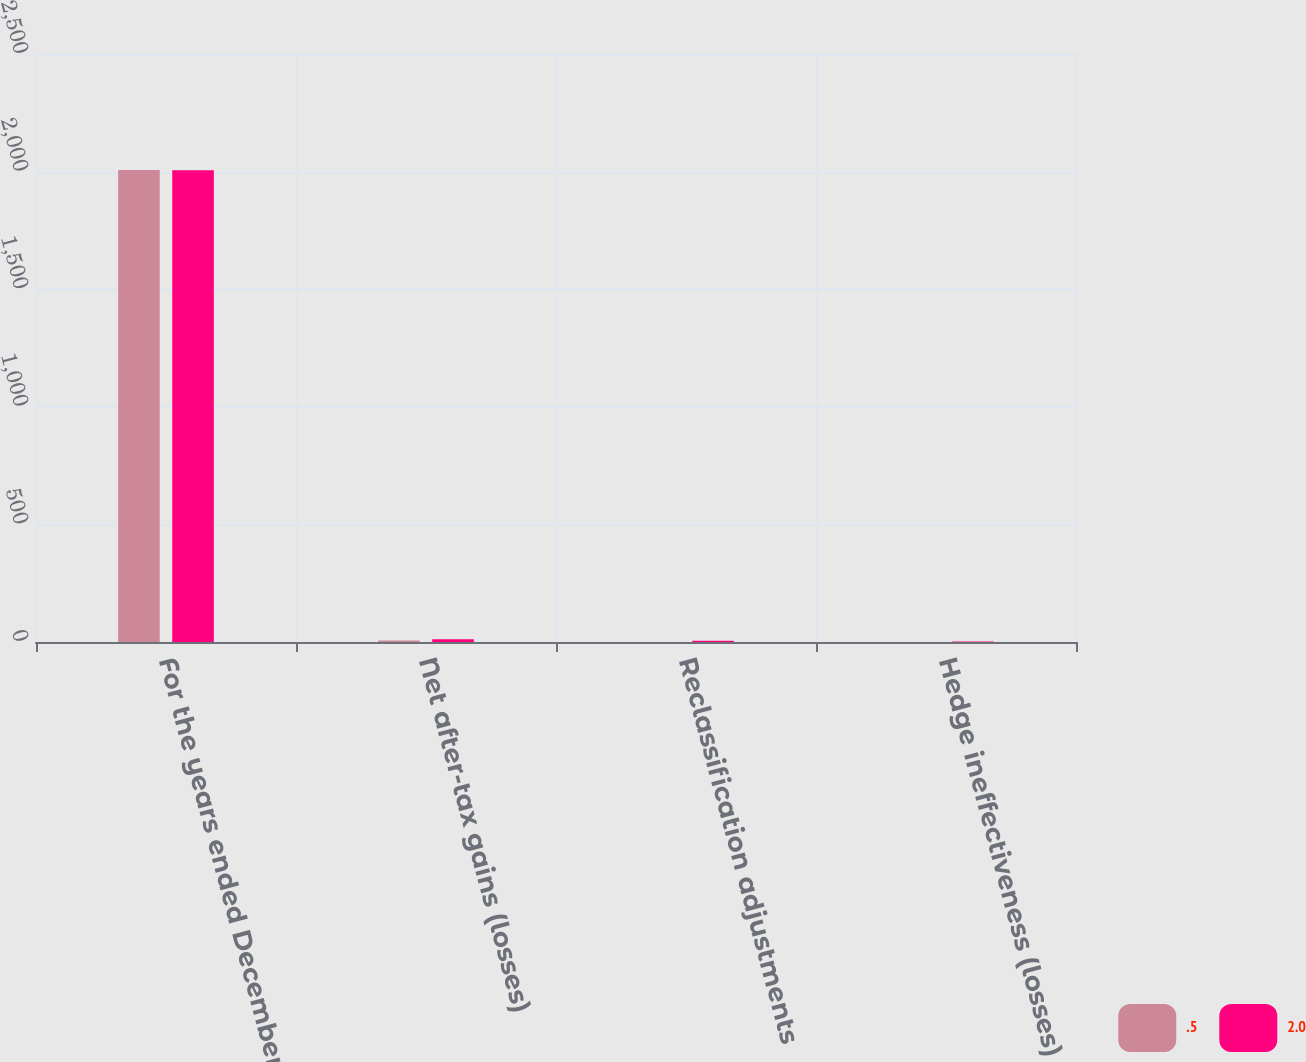Convert chart. <chart><loc_0><loc_0><loc_500><loc_500><stacked_bar_chart><ecel><fcel>For the years ended December<fcel>Net after-tax gains (losses)<fcel>Reclassification adjustments<fcel>Hedge ineffectiveness (losses)<nl><fcel>0.5<fcel>2007<fcel>6.8<fcel>0.2<fcel>0.5<nl><fcel>2<fcel>2006<fcel>11.4<fcel>5.3<fcel>2<nl></chart> 